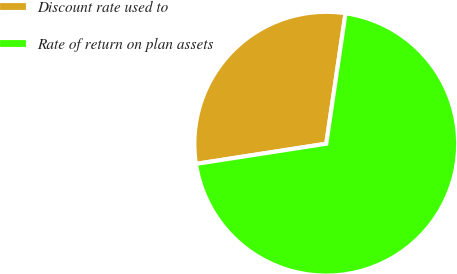Convert chart. <chart><loc_0><loc_0><loc_500><loc_500><pie_chart><fcel>Discount rate used to<fcel>Rate of return on plan assets<nl><fcel>29.78%<fcel>70.22%<nl></chart> 